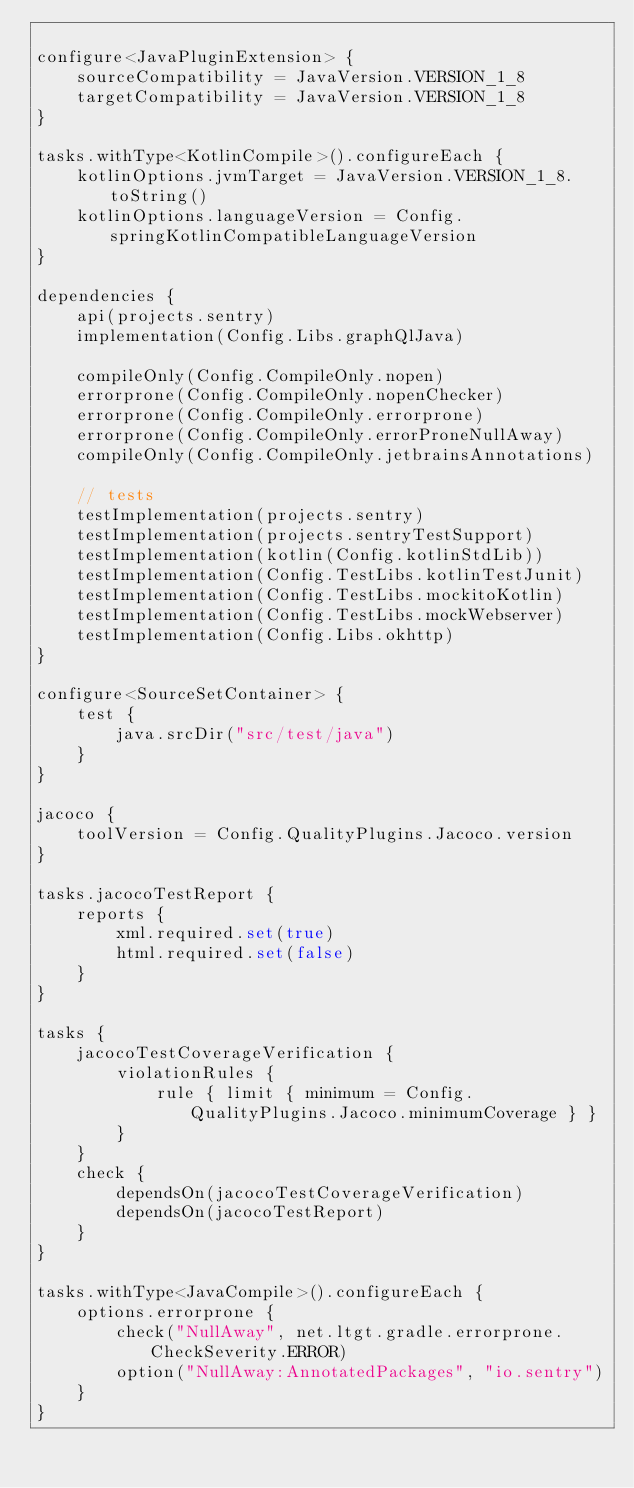Convert code to text. <code><loc_0><loc_0><loc_500><loc_500><_Kotlin_>
configure<JavaPluginExtension> {
    sourceCompatibility = JavaVersion.VERSION_1_8
    targetCompatibility = JavaVersion.VERSION_1_8
}

tasks.withType<KotlinCompile>().configureEach {
    kotlinOptions.jvmTarget = JavaVersion.VERSION_1_8.toString()
    kotlinOptions.languageVersion = Config.springKotlinCompatibleLanguageVersion
}

dependencies {
    api(projects.sentry)
    implementation(Config.Libs.graphQlJava)

    compileOnly(Config.CompileOnly.nopen)
    errorprone(Config.CompileOnly.nopenChecker)
    errorprone(Config.CompileOnly.errorprone)
    errorprone(Config.CompileOnly.errorProneNullAway)
    compileOnly(Config.CompileOnly.jetbrainsAnnotations)

    // tests
    testImplementation(projects.sentry)
    testImplementation(projects.sentryTestSupport)
    testImplementation(kotlin(Config.kotlinStdLib))
    testImplementation(Config.TestLibs.kotlinTestJunit)
    testImplementation(Config.TestLibs.mockitoKotlin)
    testImplementation(Config.TestLibs.mockWebserver)
    testImplementation(Config.Libs.okhttp)
}

configure<SourceSetContainer> {
    test {
        java.srcDir("src/test/java")
    }
}

jacoco {
    toolVersion = Config.QualityPlugins.Jacoco.version
}

tasks.jacocoTestReport {
    reports {
        xml.required.set(true)
        html.required.set(false)
    }
}

tasks {
    jacocoTestCoverageVerification {
        violationRules {
            rule { limit { minimum = Config.QualityPlugins.Jacoco.minimumCoverage } }
        }
    }
    check {
        dependsOn(jacocoTestCoverageVerification)
        dependsOn(jacocoTestReport)
    }
}

tasks.withType<JavaCompile>().configureEach {
    options.errorprone {
        check("NullAway", net.ltgt.gradle.errorprone.CheckSeverity.ERROR)
        option("NullAway:AnnotatedPackages", "io.sentry")
    }
}
</code> 